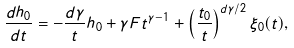<formula> <loc_0><loc_0><loc_500><loc_500>\frac { d h _ { 0 } } { d t } = - \frac { d \gamma } { t } h _ { 0 } + \gamma F t ^ { \gamma - 1 } + \left ( \frac { t _ { 0 } } { t } \right ) ^ { d \gamma / 2 } \xi _ { 0 } ( t ) ,</formula> 